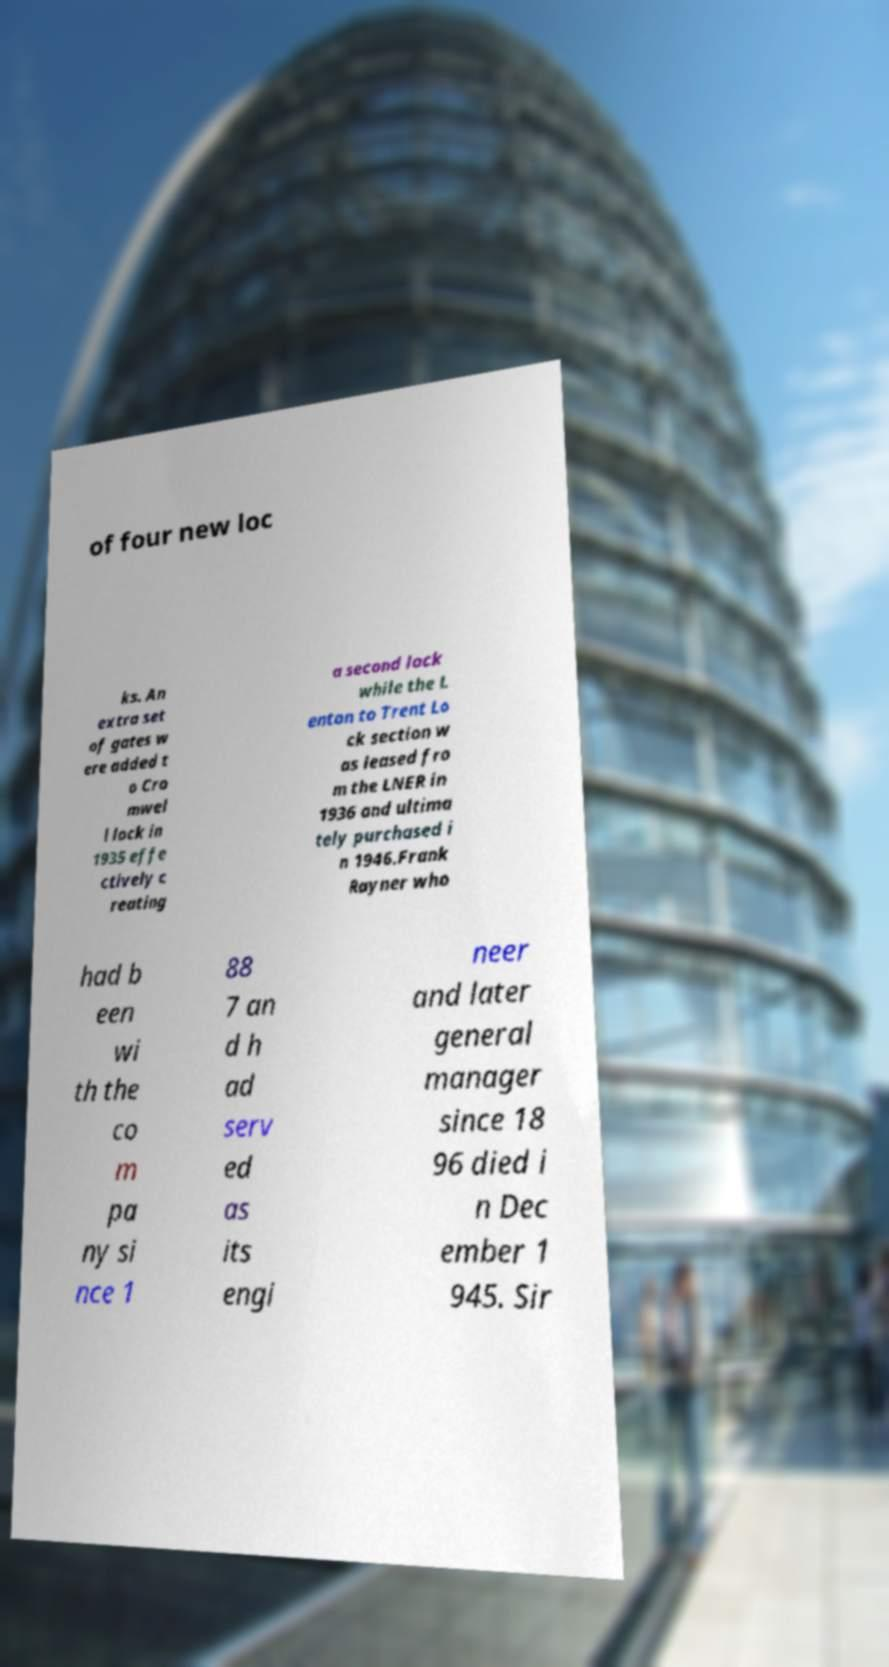Please identify and transcribe the text found in this image. of four new loc ks. An extra set of gates w ere added t o Cro mwel l lock in 1935 effe ctively c reating a second lock while the L enton to Trent Lo ck section w as leased fro m the LNER in 1936 and ultima tely purchased i n 1946.Frank Rayner who had b een wi th the co m pa ny si nce 1 88 7 an d h ad serv ed as its engi neer and later general manager since 18 96 died i n Dec ember 1 945. Sir 